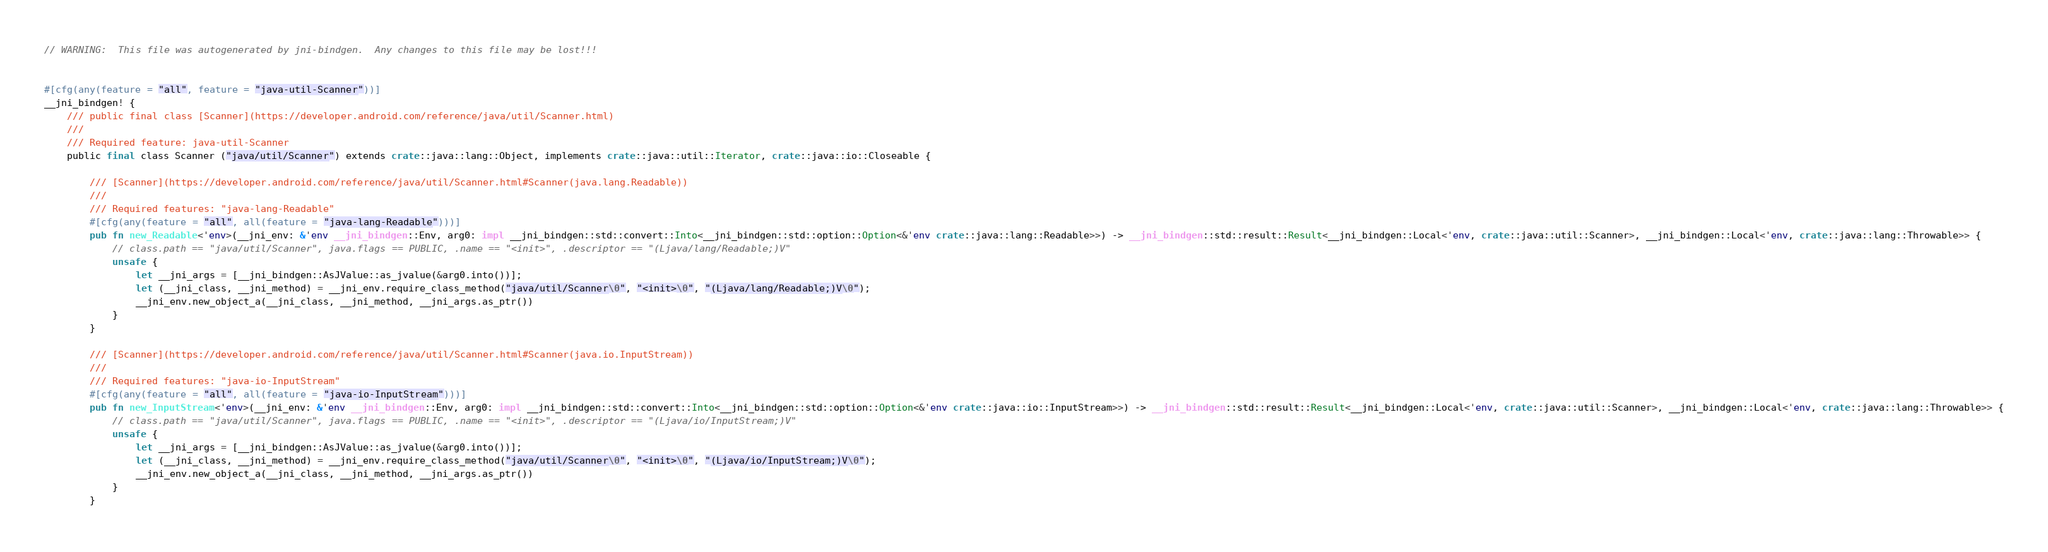<code> <loc_0><loc_0><loc_500><loc_500><_Rust_>// WARNING:  This file was autogenerated by jni-bindgen.  Any changes to this file may be lost!!!


#[cfg(any(feature = "all", feature = "java-util-Scanner"))]
__jni_bindgen! {
    /// public final class [Scanner](https://developer.android.com/reference/java/util/Scanner.html)
    ///
    /// Required feature: java-util-Scanner
    public final class Scanner ("java/util/Scanner") extends crate::java::lang::Object, implements crate::java::util::Iterator, crate::java::io::Closeable {

        /// [Scanner](https://developer.android.com/reference/java/util/Scanner.html#Scanner(java.lang.Readable))
        ///
        /// Required features: "java-lang-Readable"
        #[cfg(any(feature = "all", all(feature = "java-lang-Readable")))]
        pub fn new_Readable<'env>(__jni_env: &'env __jni_bindgen::Env, arg0: impl __jni_bindgen::std::convert::Into<__jni_bindgen::std::option::Option<&'env crate::java::lang::Readable>>) -> __jni_bindgen::std::result::Result<__jni_bindgen::Local<'env, crate::java::util::Scanner>, __jni_bindgen::Local<'env, crate::java::lang::Throwable>> {
            // class.path == "java/util/Scanner", java.flags == PUBLIC, .name == "<init>", .descriptor == "(Ljava/lang/Readable;)V"
            unsafe {
                let __jni_args = [__jni_bindgen::AsJValue::as_jvalue(&arg0.into())];
                let (__jni_class, __jni_method) = __jni_env.require_class_method("java/util/Scanner\0", "<init>\0", "(Ljava/lang/Readable;)V\0");
                __jni_env.new_object_a(__jni_class, __jni_method, __jni_args.as_ptr())
            }
        }

        /// [Scanner](https://developer.android.com/reference/java/util/Scanner.html#Scanner(java.io.InputStream))
        ///
        /// Required features: "java-io-InputStream"
        #[cfg(any(feature = "all", all(feature = "java-io-InputStream")))]
        pub fn new_InputStream<'env>(__jni_env: &'env __jni_bindgen::Env, arg0: impl __jni_bindgen::std::convert::Into<__jni_bindgen::std::option::Option<&'env crate::java::io::InputStream>>) -> __jni_bindgen::std::result::Result<__jni_bindgen::Local<'env, crate::java::util::Scanner>, __jni_bindgen::Local<'env, crate::java::lang::Throwable>> {
            // class.path == "java/util/Scanner", java.flags == PUBLIC, .name == "<init>", .descriptor == "(Ljava/io/InputStream;)V"
            unsafe {
                let __jni_args = [__jni_bindgen::AsJValue::as_jvalue(&arg0.into())];
                let (__jni_class, __jni_method) = __jni_env.require_class_method("java/util/Scanner\0", "<init>\0", "(Ljava/io/InputStream;)V\0");
                __jni_env.new_object_a(__jni_class, __jni_method, __jni_args.as_ptr())
            }
        }
</code> 